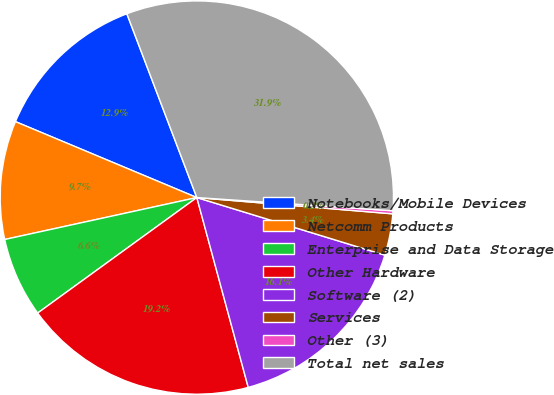<chart> <loc_0><loc_0><loc_500><loc_500><pie_chart><fcel>Notebooks/Mobile Devices<fcel>Netcomm Products<fcel>Enterprise and Data Storage<fcel>Other Hardware<fcel>Software (2)<fcel>Services<fcel>Other (3)<fcel>Total net sales<nl><fcel>12.9%<fcel>9.73%<fcel>6.57%<fcel>19.22%<fcel>16.06%<fcel>3.41%<fcel>0.25%<fcel>31.86%<nl></chart> 